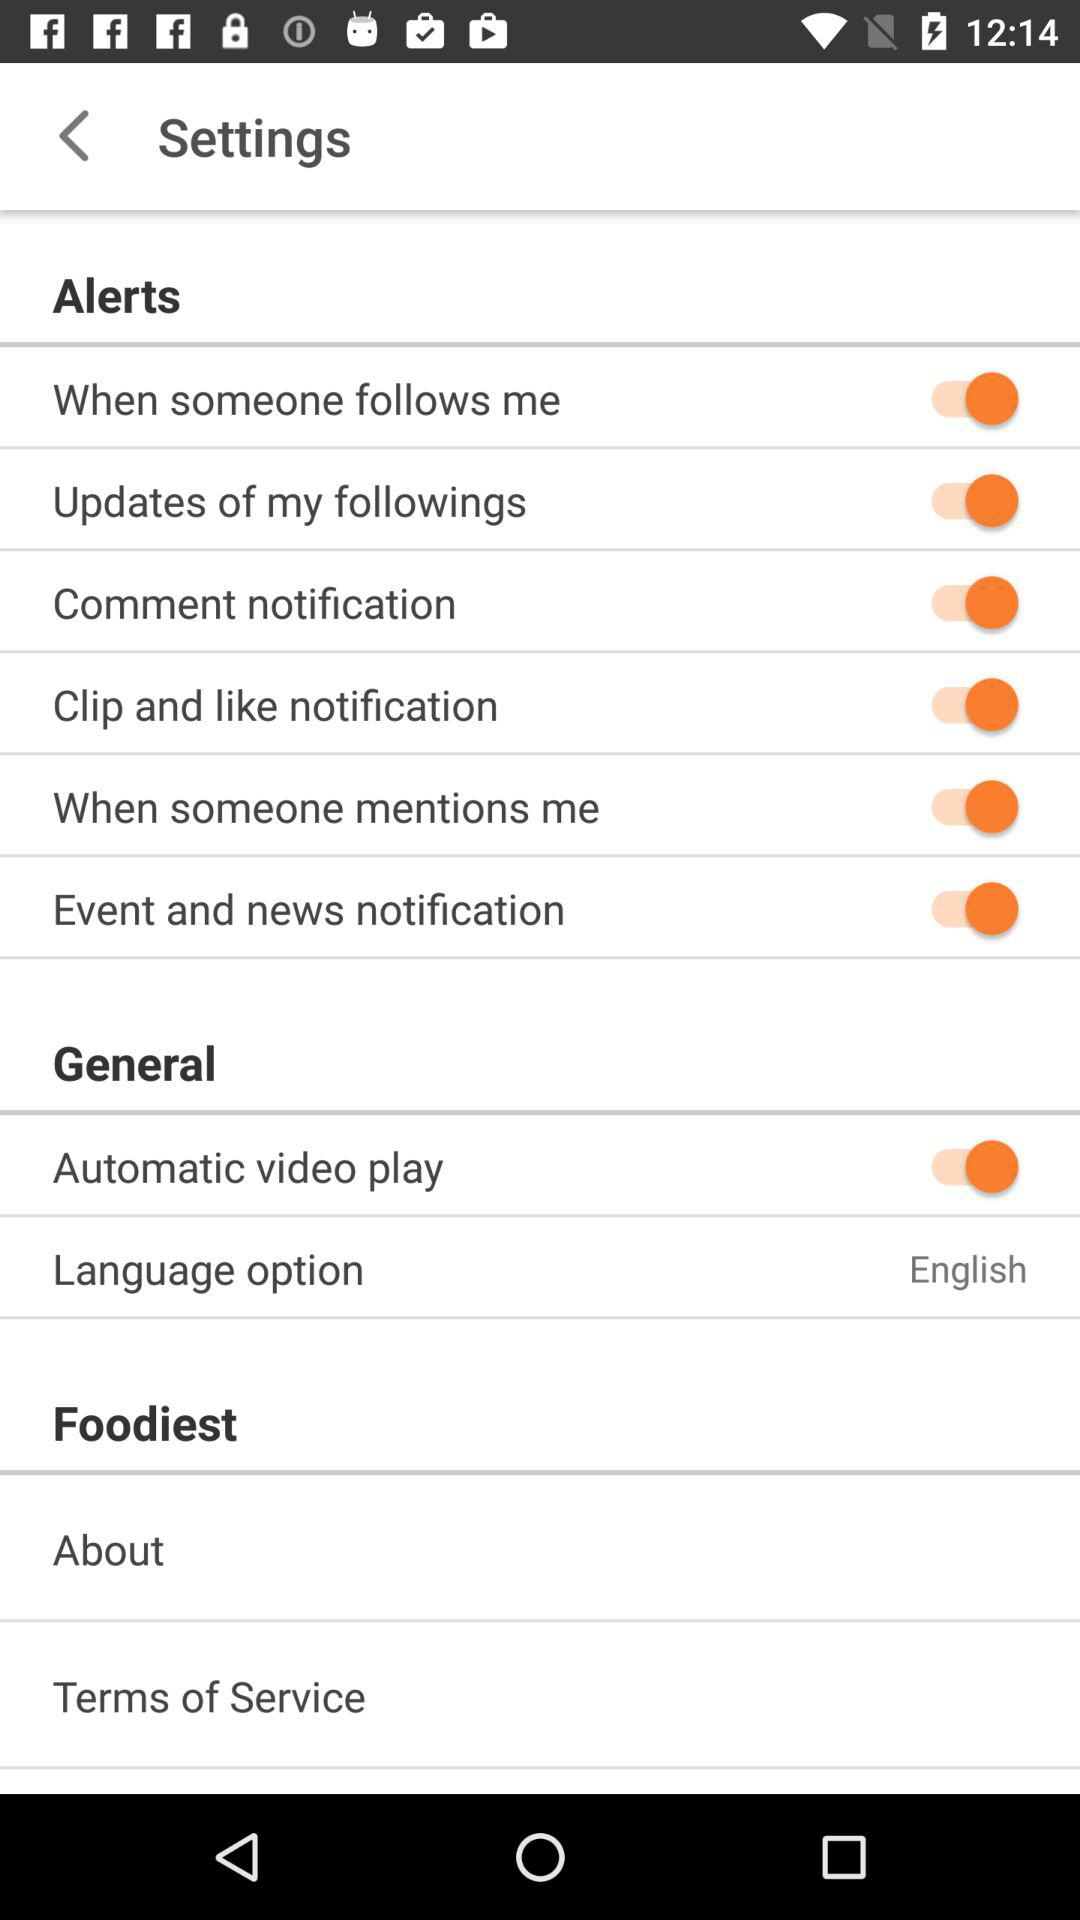How many items are under the Alerts section?
Answer the question using a single word or phrase. 6 